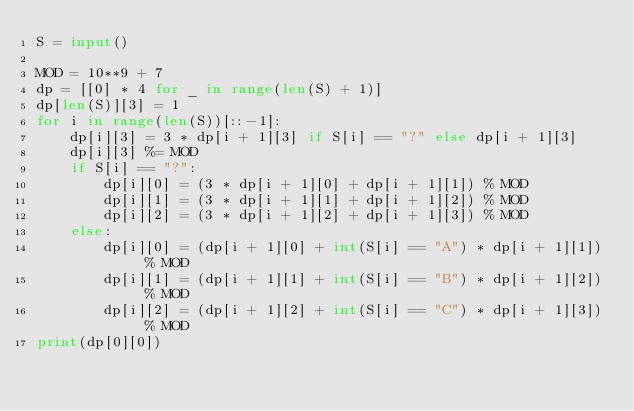Convert code to text. <code><loc_0><loc_0><loc_500><loc_500><_Python_>S = input()

MOD = 10**9 + 7
dp = [[0] * 4 for _ in range(len(S) + 1)]
dp[len(S)][3] = 1
for i in range(len(S))[::-1]:
    dp[i][3] = 3 * dp[i + 1][3] if S[i] == "?" else dp[i + 1][3]
    dp[i][3] %= MOD
    if S[i] == "?":
        dp[i][0] = (3 * dp[i + 1][0] + dp[i + 1][1]) % MOD
        dp[i][1] = (3 * dp[i + 1][1] + dp[i + 1][2]) % MOD
        dp[i][2] = (3 * dp[i + 1][2] + dp[i + 1][3]) % MOD
    else:
        dp[i][0] = (dp[i + 1][0] + int(S[i] == "A") * dp[i + 1][1]) % MOD
        dp[i][1] = (dp[i + 1][1] + int(S[i] == "B") * dp[i + 1][2]) % MOD
        dp[i][2] = (dp[i + 1][2] + int(S[i] == "C") * dp[i + 1][3]) % MOD
print(dp[0][0])
</code> 